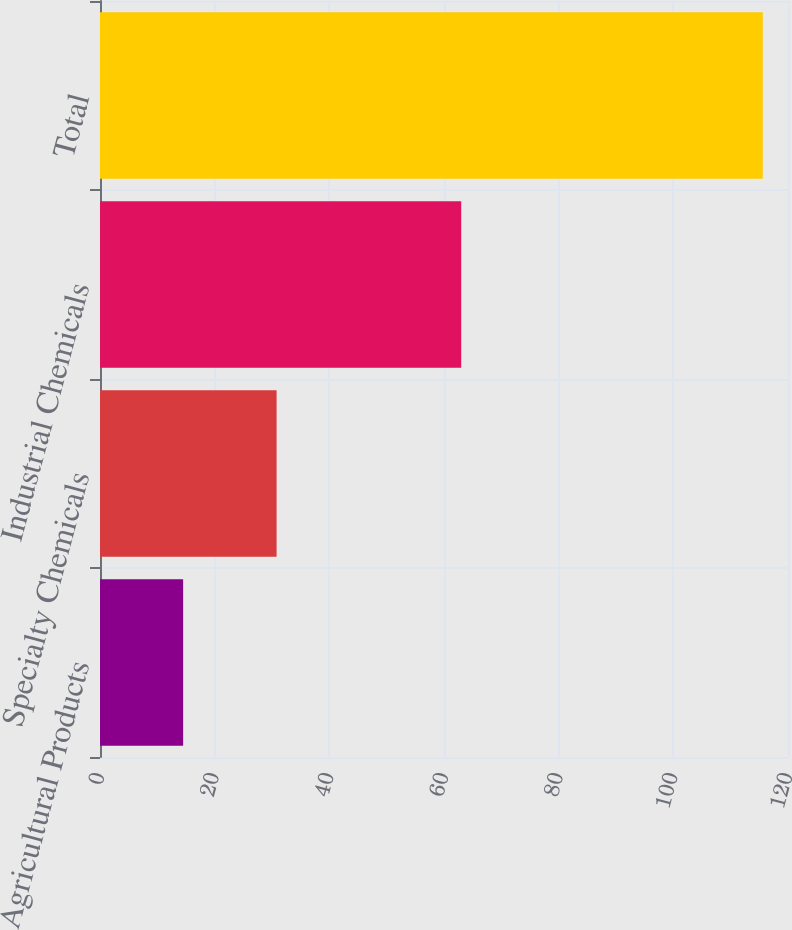<chart> <loc_0><loc_0><loc_500><loc_500><bar_chart><fcel>Agricultural Products<fcel>Specialty Chemicals<fcel>Industrial Chemicals<fcel>Total<nl><fcel>14.5<fcel>30.8<fcel>63<fcel>115.6<nl></chart> 